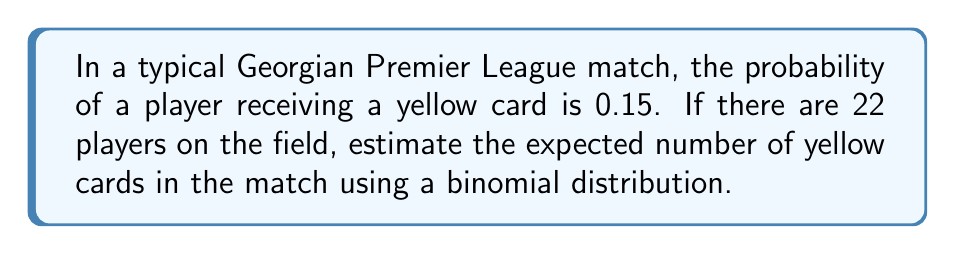Show me your answer to this math problem. Let's approach this step-by-step using the binomial distribution:

1) The binomial distribution is used when we have a fixed number of independent trials, each with the same probability of success.

2) In this case:
   - Number of trials (n) = 22 (players on the field)
   - Probability of success (p) = 0.15 (probability of a player receiving a yellow card)

3) The expected value (mean) of a binomial distribution is given by:

   $$E(X) = np$$

   Where:
   - E(X) is the expected value
   - n is the number of trials
   - p is the probability of success

4) Substituting our values:

   $$E(X) = 22 \times 0.15 = 3.3$$

5) Therefore, the expected number of yellow cards in the match is 3.3.

Note: While we can't have a fractional number of yellow cards in reality, this expectation gives us an average over many matches.
Answer: 3.3 yellow cards 